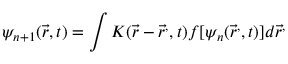Convert formula to latex. <formula><loc_0><loc_0><loc_500><loc_500>\psi _ { n + 1 } ( { \vec { r } } , t ) = \int K ( { \vec { r } } - { \vec { r } } ^ { , } , t ) f [ \psi _ { n } ( { \vec { r } } ^ { , } , t ) ] d { \vec { r } } ^ { , }</formula> 